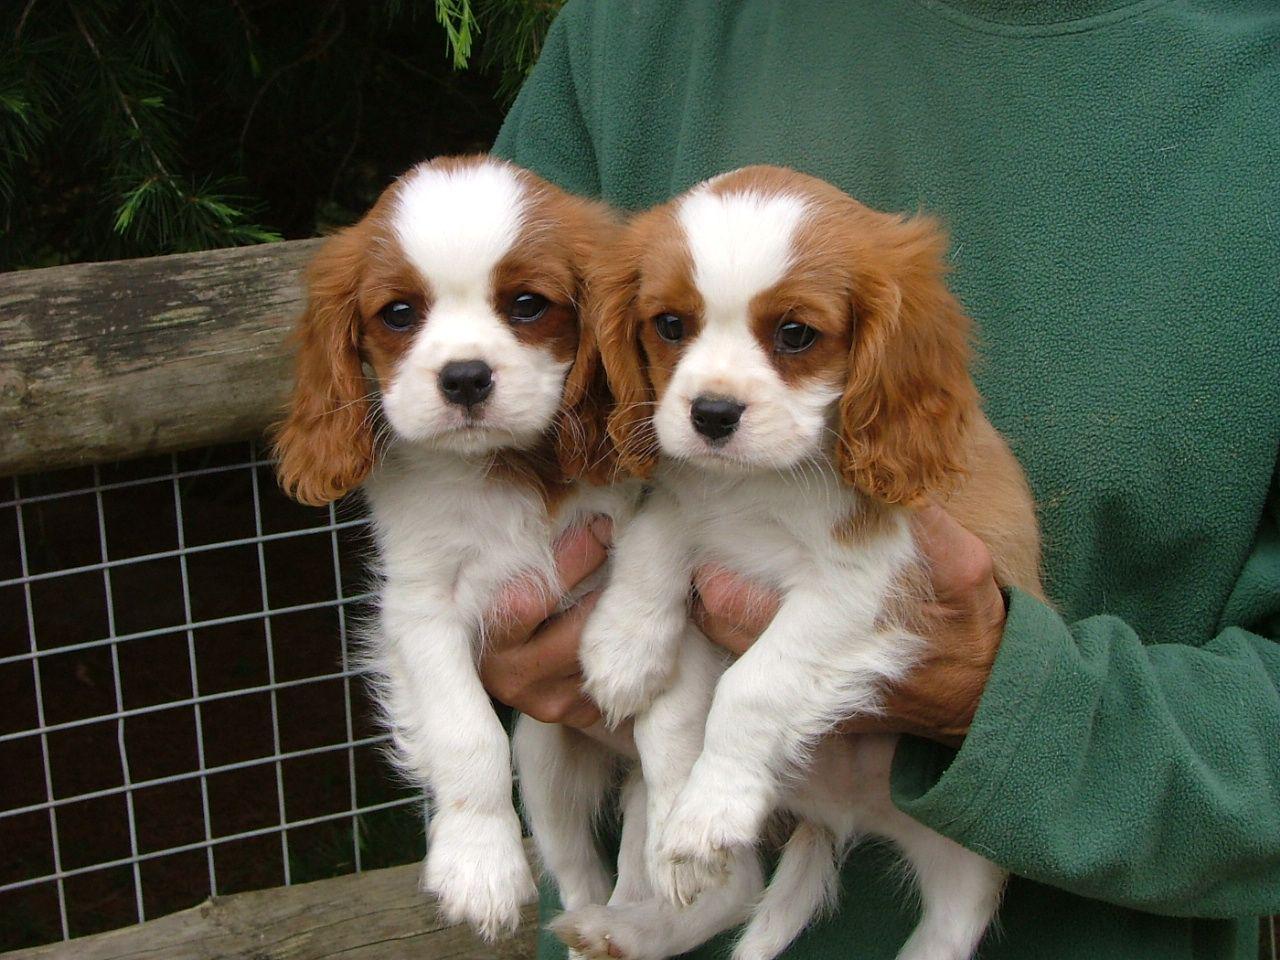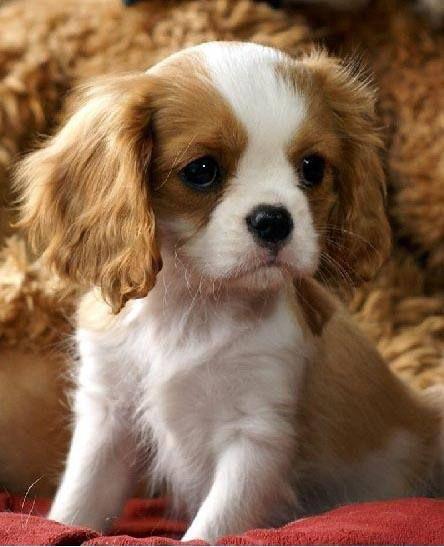The first image is the image on the left, the second image is the image on the right. Assess this claim about the two images: "Two or more dogs are being held by one or more humans in one of the images.". Correct or not? Answer yes or no. Yes. The first image is the image on the left, the second image is the image on the right. Considering the images on both sides, is "There are two dogs." valid? Answer yes or no. No. 